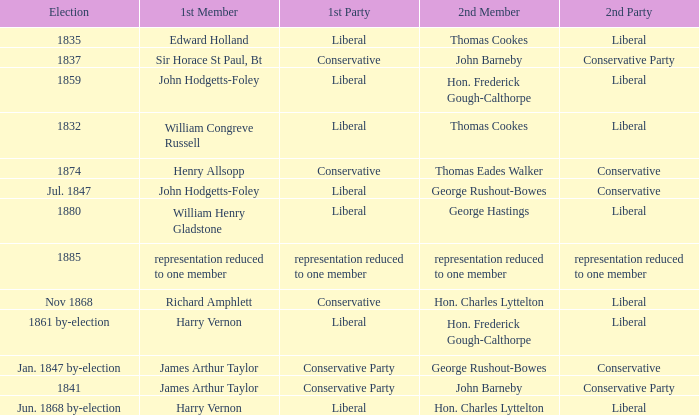What was the 2nd Party that had the 2nd Member John Barneby, when the 1st Party was Conservative? Conservative Party. 